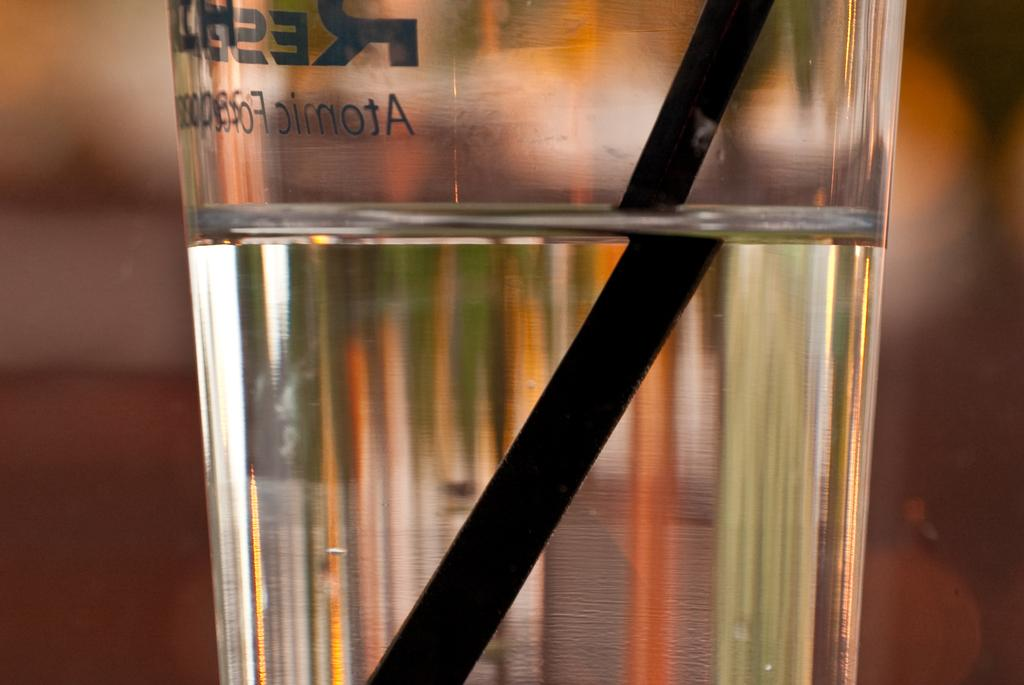Provide a one-sentence caption for the provided image. Glass of water in Atomic glass with a black straw in it. 